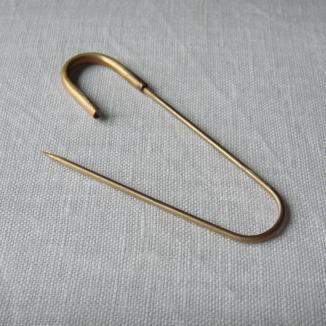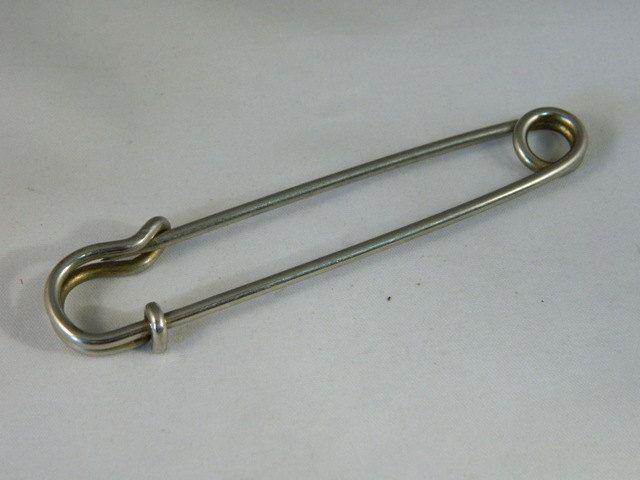The first image is the image on the left, the second image is the image on the right. Assess this claim about the two images: "One safety pin is open and one is closed.". Correct or not? Answer yes or no. Yes. The first image is the image on the left, the second image is the image on the right. For the images displayed, is the sentence "There are two safety pins" factually correct? Answer yes or no. Yes. 